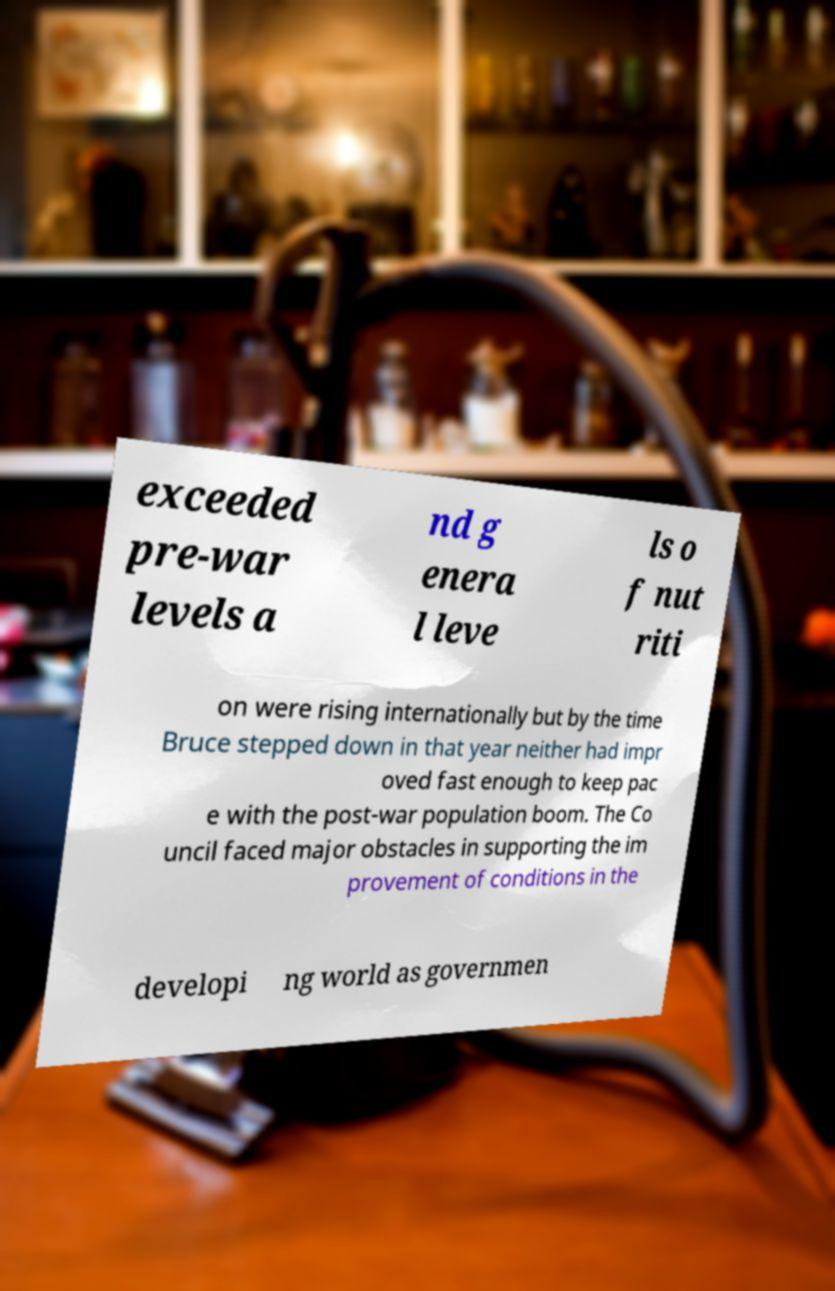I need the written content from this picture converted into text. Can you do that? exceeded pre-war levels a nd g enera l leve ls o f nut riti on were rising internationally but by the time Bruce stepped down in that year neither had impr oved fast enough to keep pac e with the post-war population boom. The Co uncil faced major obstacles in supporting the im provement of conditions in the developi ng world as governmen 